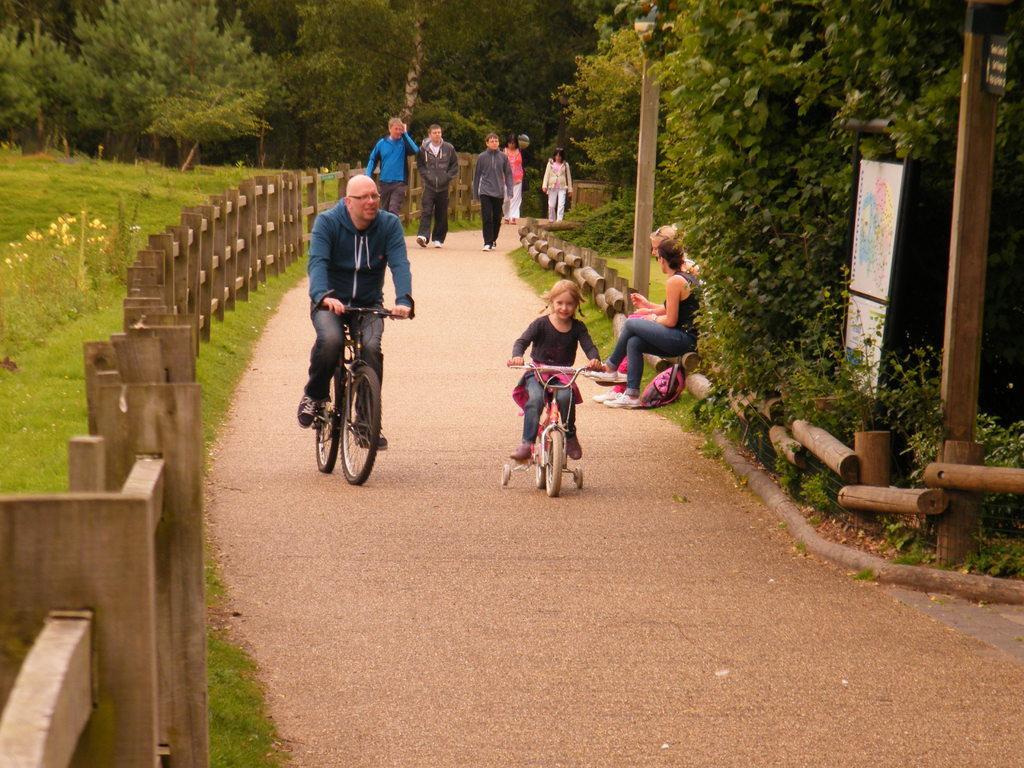How would you summarize this image in a sentence or two? In this image there are two people cycling on the road. Behind them there are a few people walking and there are two people sitting. Beside the road there is a wooden fence. There is grass on the surface. There are plants and flowers. On the right side of the image there is a board. In the background of the image there are trees. 